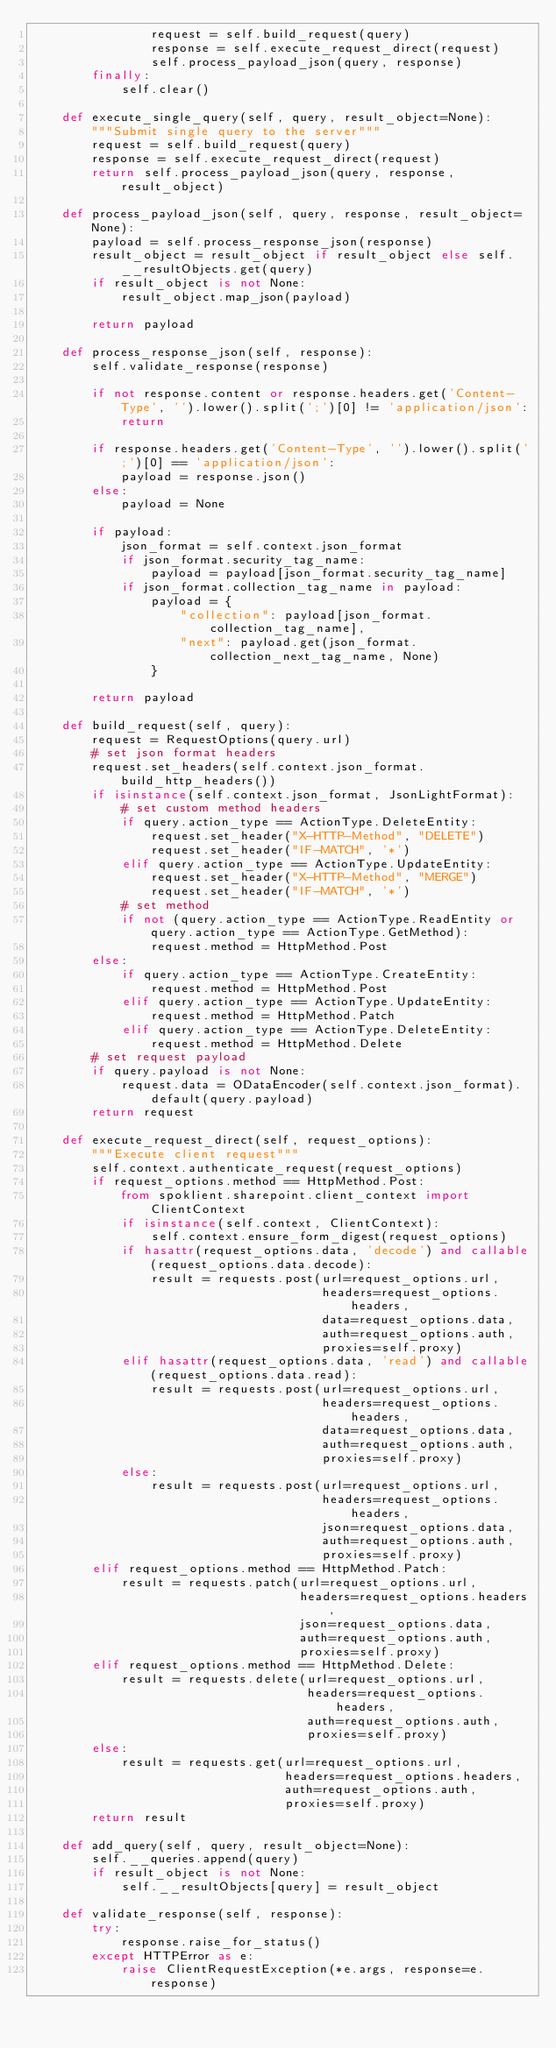Convert code to text. <code><loc_0><loc_0><loc_500><loc_500><_Python_>                request = self.build_request(query)
                response = self.execute_request_direct(request)
                self.process_payload_json(query, response)
        finally:
            self.clear()

    def execute_single_query(self, query, result_object=None):
        """Submit single query to the server"""
        request = self.build_request(query)
        response = self.execute_request_direct(request)
        return self.process_payload_json(query, response, result_object)

    def process_payload_json(self, query, response, result_object=None):
        payload = self.process_response_json(response)
        result_object = result_object if result_object else self.__resultObjects.get(query)
        if result_object is not None:
            result_object.map_json(payload)

        return payload

    def process_response_json(self, response):
        self.validate_response(response)

        if not response.content or response.headers.get('Content-Type', '').lower().split(';')[0] != 'application/json':
            return

        if response.headers.get('Content-Type', '').lower().split(';')[0] == 'application/json':
            payload = response.json()
        else:
            payload = None

        if payload:
            json_format = self.context.json_format
            if json_format.security_tag_name:
                payload = payload[json_format.security_tag_name]
            if json_format.collection_tag_name in payload:
                payload = {
                    "collection": payload[json_format.collection_tag_name],
                    "next": payload.get(json_format.collection_next_tag_name, None)
                }

        return payload

    def build_request(self, query):
        request = RequestOptions(query.url)
        # set json format headers
        request.set_headers(self.context.json_format.build_http_headers())
        if isinstance(self.context.json_format, JsonLightFormat):
            # set custom method headers
            if query.action_type == ActionType.DeleteEntity:
                request.set_header("X-HTTP-Method", "DELETE")
                request.set_header("IF-MATCH", '*')
            elif query.action_type == ActionType.UpdateEntity:
                request.set_header("X-HTTP-Method", "MERGE")
                request.set_header("IF-MATCH", '*')
            # set method
            if not (query.action_type == ActionType.ReadEntity or query.action_type == ActionType.GetMethod):
                request.method = HttpMethod.Post
        else:
            if query.action_type == ActionType.CreateEntity:
                request.method = HttpMethod.Post
            elif query.action_type == ActionType.UpdateEntity:
                request.method = HttpMethod.Patch
            elif query.action_type == ActionType.DeleteEntity:
                request.method = HttpMethod.Delete
        # set request payload
        if query.payload is not None:
            request.data = ODataEncoder(self.context.json_format).default(query.payload)
        return request

    def execute_request_direct(self, request_options):
        """Execute client request"""
        self.context.authenticate_request(request_options)
        if request_options.method == HttpMethod.Post:
            from spoklient.sharepoint.client_context import ClientContext
            if isinstance(self.context, ClientContext):
                self.context.ensure_form_digest(request_options)
            if hasattr(request_options.data, 'decode') and callable(request_options.data.decode):
                result = requests.post(url=request_options.url,
                                       headers=request_options.headers,
                                       data=request_options.data,
                                       auth=request_options.auth,
                                       proxies=self.proxy)
            elif hasattr(request_options.data, 'read') and callable(request_options.data.read):
                result = requests.post(url=request_options.url,
                                       headers=request_options.headers,
                                       data=request_options.data,
                                       auth=request_options.auth,
                                       proxies=self.proxy)
            else:
                result = requests.post(url=request_options.url,
                                       headers=request_options.headers,
                                       json=request_options.data,
                                       auth=request_options.auth,
                                       proxies=self.proxy)
        elif request_options.method == HttpMethod.Patch:
            result = requests.patch(url=request_options.url,
                                    headers=request_options.headers,
                                    json=request_options.data,
                                    auth=request_options.auth,
                                    proxies=self.proxy)
        elif request_options.method == HttpMethod.Delete:
            result = requests.delete(url=request_options.url,
                                     headers=request_options.headers,
                                     auth=request_options.auth,
                                     proxies=self.proxy)
        else:
            result = requests.get(url=request_options.url,
                                  headers=request_options.headers,
                                  auth=request_options.auth,
                                  proxies=self.proxy)
        return result

    def add_query(self, query, result_object=None):
        self.__queries.append(query)
        if result_object is not None:
            self.__resultObjects[query] = result_object

    def validate_response(self, response):
        try:
            response.raise_for_status()
        except HTTPError as e:
            raise ClientRequestException(*e.args, response=e.response)
</code> 